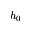<formula> <loc_0><loc_0><loc_500><loc_500>h _ { 0 }</formula> 